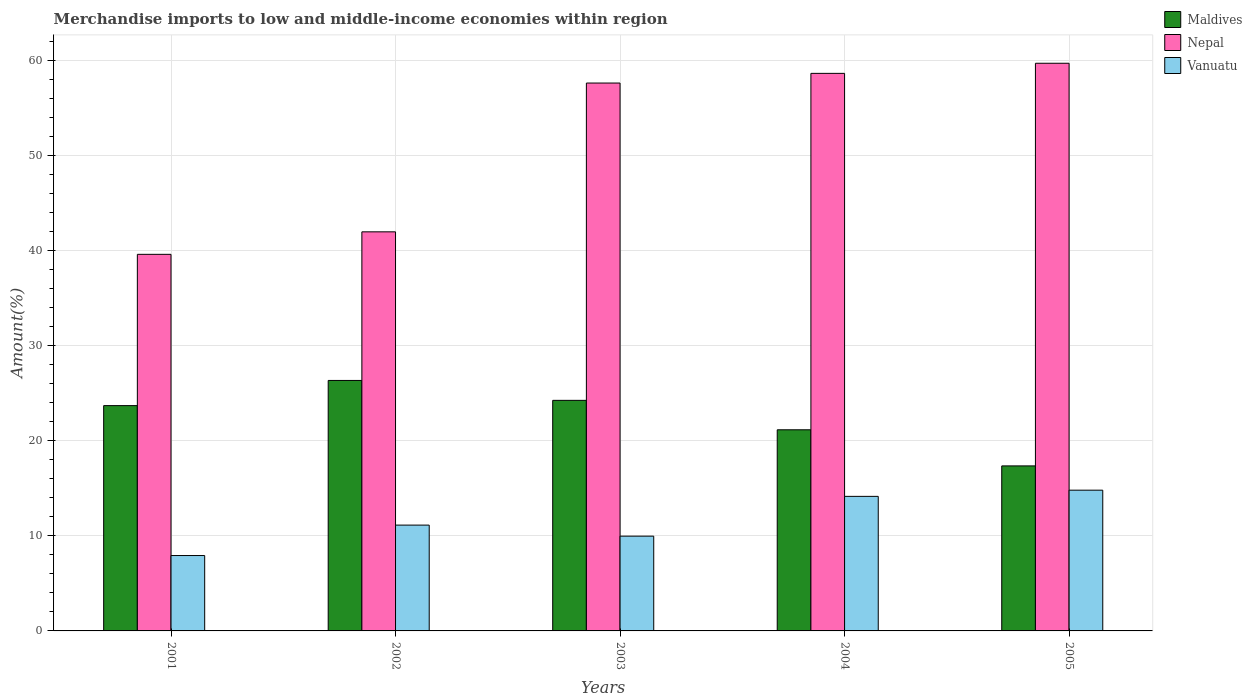How many different coloured bars are there?
Provide a succinct answer. 3. How many groups of bars are there?
Ensure brevity in your answer.  5. Are the number of bars per tick equal to the number of legend labels?
Your answer should be compact. Yes. Are the number of bars on each tick of the X-axis equal?
Keep it short and to the point. Yes. How many bars are there on the 2nd tick from the left?
Keep it short and to the point. 3. How many bars are there on the 5th tick from the right?
Your answer should be very brief. 3. What is the percentage of amount earned from merchandise imports in Maldives in 2004?
Ensure brevity in your answer.  21.16. Across all years, what is the maximum percentage of amount earned from merchandise imports in Vanuatu?
Provide a short and direct response. 14.81. Across all years, what is the minimum percentage of amount earned from merchandise imports in Vanuatu?
Ensure brevity in your answer.  7.93. What is the total percentage of amount earned from merchandise imports in Maldives in the graph?
Make the answer very short. 112.84. What is the difference between the percentage of amount earned from merchandise imports in Maldives in 2002 and that in 2003?
Offer a terse response. 2.09. What is the difference between the percentage of amount earned from merchandise imports in Nepal in 2005 and the percentage of amount earned from merchandise imports in Vanuatu in 2004?
Make the answer very short. 45.57. What is the average percentage of amount earned from merchandise imports in Nepal per year?
Keep it short and to the point. 51.53. In the year 2004, what is the difference between the percentage of amount earned from merchandise imports in Maldives and percentage of amount earned from merchandise imports in Nepal?
Offer a very short reply. -37.5. In how many years, is the percentage of amount earned from merchandise imports in Vanuatu greater than 44 %?
Keep it short and to the point. 0. What is the ratio of the percentage of amount earned from merchandise imports in Maldives in 2001 to that in 2005?
Make the answer very short. 1.37. Is the percentage of amount earned from merchandise imports in Vanuatu in 2002 less than that in 2005?
Your answer should be compact. Yes. Is the difference between the percentage of amount earned from merchandise imports in Maldives in 2002 and 2003 greater than the difference between the percentage of amount earned from merchandise imports in Nepal in 2002 and 2003?
Provide a short and direct response. Yes. What is the difference between the highest and the second highest percentage of amount earned from merchandise imports in Nepal?
Your answer should be very brief. 1.06. What is the difference between the highest and the lowest percentage of amount earned from merchandise imports in Nepal?
Your answer should be very brief. 20.1. In how many years, is the percentage of amount earned from merchandise imports in Nepal greater than the average percentage of amount earned from merchandise imports in Nepal taken over all years?
Offer a very short reply. 3. What does the 3rd bar from the left in 2002 represents?
Offer a terse response. Vanuatu. What does the 1st bar from the right in 2001 represents?
Keep it short and to the point. Vanuatu. Does the graph contain grids?
Your answer should be very brief. Yes. How many legend labels are there?
Make the answer very short. 3. What is the title of the graph?
Offer a terse response. Merchandise imports to low and middle-income economies within region. Does "Liberia" appear as one of the legend labels in the graph?
Your answer should be compact. No. What is the label or title of the X-axis?
Make the answer very short. Years. What is the label or title of the Y-axis?
Offer a very short reply. Amount(%). What is the Amount(%) of Maldives in 2001?
Offer a very short reply. 23.7. What is the Amount(%) of Nepal in 2001?
Your answer should be very brief. 39.62. What is the Amount(%) of Vanuatu in 2001?
Provide a short and direct response. 7.93. What is the Amount(%) of Maldives in 2002?
Provide a short and direct response. 26.35. What is the Amount(%) of Nepal in 2002?
Give a very brief answer. 41.99. What is the Amount(%) of Vanuatu in 2002?
Keep it short and to the point. 11.13. What is the Amount(%) in Maldives in 2003?
Provide a short and direct response. 24.26. What is the Amount(%) in Nepal in 2003?
Provide a short and direct response. 57.64. What is the Amount(%) of Vanuatu in 2003?
Make the answer very short. 9.97. What is the Amount(%) in Maldives in 2004?
Keep it short and to the point. 21.16. What is the Amount(%) of Nepal in 2004?
Provide a succinct answer. 58.66. What is the Amount(%) in Vanuatu in 2004?
Make the answer very short. 14.16. What is the Amount(%) in Maldives in 2005?
Offer a terse response. 17.36. What is the Amount(%) in Nepal in 2005?
Keep it short and to the point. 59.72. What is the Amount(%) in Vanuatu in 2005?
Ensure brevity in your answer.  14.81. Across all years, what is the maximum Amount(%) in Maldives?
Ensure brevity in your answer.  26.35. Across all years, what is the maximum Amount(%) of Nepal?
Offer a very short reply. 59.72. Across all years, what is the maximum Amount(%) of Vanuatu?
Provide a succinct answer. 14.81. Across all years, what is the minimum Amount(%) in Maldives?
Ensure brevity in your answer.  17.36. Across all years, what is the minimum Amount(%) of Nepal?
Ensure brevity in your answer.  39.62. Across all years, what is the minimum Amount(%) of Vanuatu?
Ensure brevity in your answer.  7.93. What is the total Amount(%) in Maldives in the graph?
Offer a very short reply. 112.84. What is the total Amount(%) of Nepal in the graph?
Give a very brief answer. 257.64. What is the total Amount(%) in Vanuatu in the graph?
Offer a very short reply. 58. What is the difference between the Amount(%) in Maldives in 2001 and that in 2002?
Ensure brevity in your answer.  -2.65. What is the difference between the Amount(%) of Nepal in 2001 and that in 2002?
Ensure brevity in your answer.  -2.37. What is the difference between the Amount(%) of Vanuatu in 2001 and that in 2002?
Your answer should be very brief. -3.2. What is the difference between the Amount(%) in Maldives in 2001 and that in 2003?
Keep it short and to the point. -0.56. What is the difference between the Amount(%) in Nepal in 2001 and that in 2003?
Your answer should be compact. -18.02. What is the difference between the Amount(%) of Vanuatu in 2001 and that in 2003?
Offer a terse response. -2.04. What is the difference between the Amount(%) in Maldives in 2001 and that in 2004?
Provide a short and direct response. 2.54. What is the difference between the Amount(%) in Nepal in 2001 and that in 2004?
Provide a short and direct response. -19.04. What is the difference between the Amount(%) of Vanuatu in 2001 and that in 2004?
Offer a very short reply. -6.23. What is the difference between the Amount(%) in Maldives in 2001 and that in 2005?
Ensure brevity in your answer.  6.34. What is the difference between the Amount(%) in Nepal in 2001 and that in 2005?
Your answer should be compact. -20.1. What is the difference between the Amount(%) in Vanuatu in 2001 and that in 2005?
Offer a terse response. -6.88. What is the difference between the Amount(%) in Maldives in 2002 and that in 2003?
Your answer should be very brief. 2.09. What is the difference between the Amount(%) in Nepal in 2002 and that in 2003?
Offer a terse response. -15.65. What is the difference between the Amount(%) in Vanuatu in 2002 and that in 2003?
Give a very brief answer. 1.16. What is the difference between the Amount(%) in Maldives in 2002 and that in 2004?
Your answer should be very brief. 5.19. What is the difference between the Amount(%) in Nepal in 2002 and that in 2004?
Your answer should be very brief. -16.67. What is the difference between the Amount(%) of Vanuatu in 2002 and that in 2004?
Provide a succinct answer. -3.02. What is the difference between the Amount(%) of Maldives in 2002 and that in 2005?
Keep it short and to the point. 8.99. What is the difference between the Amount(%) of Nepal in 2002 and that in 2005?
Provide a succinct answer. -17.74. What is the difference between the Amount(%) in Vanuatu in 2002 and that in 2005?
Provide a succinct answer. -3.67. What is the difference between the Amount(%) of Maldives in 2003 and that in 2004?
Your answer should be very brief. 3.1. What is the difference between the Amount(%) of Nepal in 2003 and that in 2004?
Your response must be concise. -1.02. What is the difference between the Amount(%) in Vanuatu in 2003 and that in 2004?
Your answer should be very brief. -4.19. What is the difference between the Amount(%) in Maldives in 2003 and that in 2005?
Your answer should be very brief. 6.9. What is the difference between the Amount(%) in Nepal in 2003 and that in 2005?
Your answer should be very brief. -2.08. What is the difference between the Amount(%) in Vanuatu in 2003 and that in 2005?
Your answer should be compact. -4.84. What is the difference between the Amount(%) of Maldives in 2004 and that in 2005?
Ensure brevity in your answer.  3.8. What is the difference between the Amount(%) in Nepal in 2004 and that in 2005?
Keep it short and to the point. -1.06. What is the difference between the Amount(%) in Vanuatu in 2004 and that in 2005?
Keep it short and to the point. -0.65. What is the difference between the Amount(%) of Maldives in 2001 and the Amount(%) of Nepal in 2002?
Give a very brief answer. -18.29. What is the difference between the Amount(%) of Maldives in 2001 and the Amount(%) of Vanuatu in 2002?
Offer a very short reply. 12.57. What is the difference between the Amount(%) in Nepal in 2001 and the Amount(%) in Vanuatu in 2002?
Provide a short and direct response. 28.49. What is the difference between the Amount(%) in Maldives in 2001 and the Amount(%) in Nepal in 2003?
Your response must be concise. -33.94. What is the difference between the Amount(%) in Maldives in 2001 and the Amount(%) in Vanuatu in 2003?
Ensure brevity in your answer.  13.73. What is the difference between the Amount(%) in Nepal in 2001 and the Amount(%) in Vanuatu in 2003?
Your answer should be compact. 29.65. What is the difference between the Amount(%) of Maldives in 2001 and the Amount(%) of Nepal in 2004?
Offer a very short reply. -34.96. What is the difference between the Amount(%) of Maldives in 2001 and the Amount(%) of Vanuatu in 2004?
Keep it short and to the point. 9.55. What is the difference between the Amount(%) of Nepal in 2001 and the Amount(%) of Vanuatu in 2004?
Provide a succinct answer. 25.46. What is the difference between the Amount(%) in Maldives in 2001 and the Amount(%) in Nepal in 2005?
Make the answer very short. -36.02. What is the difference between the Amount(%) in Maldives in 2001 and the Amount(%) in Vanuatu in 2005?
Provide a short and direct response. 8.9. What is the difference between the Amount(%) of Nepal in 2001 and the Amount(%) of Vanuatu in 2005?
Your answer should be compact. 24.81. What is the difference between the Amount(%) of Maldives in 2002 and the Amount(%) of Nepal in 2003?
Provide a short and direct response. -31.29. What is the difference between the Amount(%) in Maldives in 2002 and the Amount(%) in Vanuatu in 2003?
Keep it short and to the point. 16.38. What is the difference between the Amount(%) of Nepal in 2002 and the Amount(%) of Vanuatu in 2003?
Give a very brief answer. 32.02. What is the difference between the Amount(%) in Maldives in 2002 and the Amount(%) in Nepal in 2004?
Offer a very short reply. -32.31. What is the difference between the Amount(%) of Maldives in 2002 and the Amount(%) of Vanuatu in 2004?
Provide a succinct answer. 12.2. What is the difference between the Amount(%) in Nepal in 2002 and the Amount(%) in Vanuatu in 2004?
Provide a succinct answer. 27.83. What is the difference between the Amount(%) of Maldives in 2002 and the Amount(%) of Nepal in 2005?
Keep it short and to the point. -33.37. What is the difference between the Amount(%) of Maldives in 2002 and the Amount(%) of Vanuatu in 2005?
Provide a short and direct response. 11.55. What is the difference between the Amount(%) in Nepal in 2002 and the Amount(%) in Vanuatu in 2005?
Provide a succinct answer. 27.18. What is the difference between the Amount(%) in Maldives in 2003 and the Amount(%) in Nepal in 2004?
Offer a terse response. -34.4. What is the difference between the Amount(%) of Maldives in 2003 and the Amount(%) of Vanuatu in 2004?
Your answer should be compact. 10.1. What is the difference between the Amount(%) in Nepal in 2003 and the Amount(%) in Vanuatu in 2004?
Ensure brevity in your answer.  43.49. What is the difference between the Amount(%) in Maldives in 2003 and the Amount(%) in Nepal in 2005?
Provide a succinct answer. -35.47. What is the difference between the Amount(%) in Maldives in 2003 and the Amount(%) in Vanuatu in 2005?
Your answer should be very brief. 9.45. What is the difference between the Amount(%) in Nepal in 2003 and the Amount(%) in Vanuatu in 2005?
Your answer should be compact. 42.84. What is the difference between the Amount(%) of Maldives in 2004 and the Amount(%) of Nepal in 2005?
Provide a short and direct response. -38.56. What is the difference between the Amount(%) of Maldives in 2004 and the Amount(%) of Vanuatu in 2005?
Your answer should be very brief. 6.35. What is the difference between the Amount(%) in Nepal in 2004 and the Amount(%) in Vanuatu in 2005?
Provide a succinct answer. 43.85. What is the average Amount(%) in Maldives per year?
Provide a short and direct response. 22.57. What is the average Amount(%) of Nepal per year?
Your response must be concise. 51.53. What is the average Amount(%) in Vanuatu per year?
Offer a terse response. 11.6. In the year 2001, what is the difference between the Amount(%) of Maldives and Amount(%) of Nepal?
Give a very brief answer. -15.92. In the year 2001, what is the difference between the Amount(%) of Maldives and Amount(%) of Vanuatu?
Offer a terse response. 15.77. In the year 2001, what is the difference between the Amount(%) in Nepal and Amount(%) in Vanuatu?
Ensure brevity in your answer.  31.69. In the year 2002, what is the difference between the Amount(%) in Maldives and Amount(%) in Nepal?
Keep it short and to the point. -15.64. In the year 2002, what is the difference between the Amount(%) in Maldives and Amount(%) in Vanuatu?
Ensure brevity in your answer.  15.22. In the year 2002, what is the difference between the Amount(%) in Nepal and Amount(%) in Vanuatu?
Your answer should be very brief. 30.86. In the year 2003, what is the difference between the Amount(%) in Maldives and Amount(%) in Nepal?
Provide a succinct answer. -33.38. In the year 2003, what is the difference between the Amount(%) in Maldives and Amount(%) in Vanuatu?
Provide a succinct answer. 14.29. In the year 2003, what is the difference between the Amount(%) in Nepal and Amount(%) in Vanuatu?
Offer a terse response. 47.67. In the year 2004, what is the difference between the Amount(%) in Maldives and Amount(%) in Nepal?
Offer a terse response. -37.5. In the year 2004, what is the difference between the Amount(%) in Maldives and Amount(%) in Vanuatu?
Make the answer very short. 7.01. In the year 2004, what is the difference between the Amount(%) of Nepal and Amount(%) of Vanuatu?
Ensure brevity in your answer.  44.5. In the year 2005, what is the difference between the Amount(%) of Maldives and Amount(%) of Nepal?
Offer a very short reply. -42.36. In the year 2005, what is the difference between the Amount(%) of Maldives and Amount(%) of Vanuatu?
Offer a terse response. 2.55. In the year 2005, what is the difference between the Amount(%) in Nepal and Amount(%) in Vanuatu?
Provide a short and direct response. 44.92. What is the ratio of the Amount(%) of Maldives in 2001 to that in 2002?
Make the answer very short. 0.9. What is the ratio of the Amount(%) of Nepal in 2001 to that in 2002?
Offer a terse response. 0.94. What is the ratio of the Amount(%) of Vanuatu in 2001 to that in 2002?
Provide a short and direct response. 0.71. What is the ratio of the Amount(%) in Maldives in 2001 to that in 2003?
Make the answer very short. 0.98. What is the ratio of the Amount(%) of Nepal in 2001 to that in 2003?
Provide a succinct answer. 0.69. What is the ratio of the Amount(%) of Vanuatu in 2001 to that in 2003?
Make the answer very short. 0.8. What is the ratio of the Amount(%) of Maldives in 2001 to that in 2004?
Your answer should be compact. 1.12. What is the ratio of the Amount(%) in Nepal in 2001 to that in 2004?
Make the answer very short. 0.68. What is the ratio of the Amount(%) in Vanuatu in 2001 to that in 2004?
Your answer should be very brief. 0.56. What is the ratio of the Amount(%) in Maldives in 2001 to that in 2005?
Offer a very short reply. 1.37. What is the ratio of the Amount(%) of Nepal in 2001 to that in 2005?
Your response must be concise. 0.66. What is the ratio of the Amount(%) in Vanuatu in 2001 to that in 2005?
Provide a succinct answer. 0.54. What is the ratio of the Amount(%) of Maldives in 2002 to that in 2003?
Offer a terse response. 1.09. What is the ratio of the Amount(%) of Nepal in 2002 to that in 2003?
Provide a succinct answer. 0.73. What is the ratio of the Amount(%) in Vanuatu in 2002 to that in 2003?
Give a very brief answer. 1.12. What is the ratio of the Amount(%) of Maldives in 2002 to that in 2004?
Give a very brief answer. 1.25. What is the ratio of the Amount(%) of Nepal in 2002 to that in 2004?
Ensure brevity in your answer.  0.72. What is the ratio of the Amount(%) of Vanuatu in 2002 to that in 2004?
Keep it short and to the point. 0.79. What is the ratio of the Amount(%) in Maldives in 2002 to that in 2005?
Provide a succinct answer. 1.52. What is the ratio of the Amount(%) of Nepal in 2002 to that in 2005?
Ensure brevity in your answer.  0.7. What is the ratio of the Amount(%) in Vanuatu in 2002 to that in 2005?
Keep it short and to the point. 0.75. What is the ratio of the Amount(%) in Maldives in 2003 to that in 2004?
Offer a terse response. 1.15. What is the ratio of the Amount(%) of Nepal in 2003 to that in 2004?
Keep it short and to the point. 0.98. What is the ratio of the Amount(%) of Vanuatu in 2003 to that in 2004?
Your answer should be compact. 0.7. What is the ratio of the Amount(%) in Maldives in 2003 to that in 2005?
Your response must be concise. 1.4. What is the ratio of the Amount(%) of Nepal in 2003 to that in 2005?
Provide a succinct answer. 0.97. What is the ratio of the Amount(%) of Vanuatu in 2003 to that in 2005?
Offer a terse response. 0.67. What is the ratio of the Amount(%) in Maldives in 2004 to that in 2005?
Provide a succinct answer. 1.22. What is the ratio of the Amount(%) in Nepal in 2004 to that in 2005?
Offer a very short reply. 0.98. What is the ratio of the Amount(%) in Vanuatu in 2004 to that in 2005?
Your answer should be compact. 0.96. What is the difference between the highest and the second highest Amount(%) in Maldives?
Provide a short and direct response. 2.09. What is the difference between the highest and the second highest Amount(%) in Nepal?
Ensure brevity in your answer.  1.06. What is the difference between the highest and the second highest Amount(%) in Vanuatu?
Keep it short and to the point. 0.65. What is the difference between the highest and the lowest Amount(%) in Maldives?
Provide a short and direct response. 8.99. What is the difference between the highest and the lowest Amount(%) in Nepal?
Give a very brief answer. 20.1. What is the difference between the highest and the lowest Amount(%) in Vanuatu?
Ensure brevity in your answer.  6.88. 